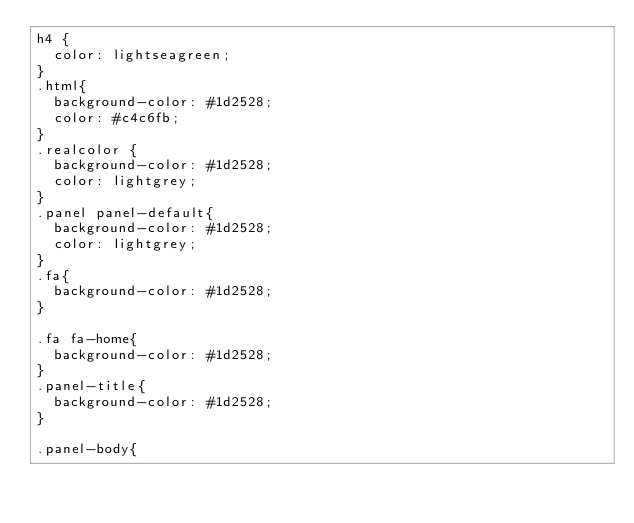Convert code to text. <code><loc_0><loc_0><loc_500><loc_500><_CSS_>h4 {
	color: lightseagreen;
}
.html{
	background-color: #1d2528;
	color: #c4c6fb;
}
.realcolor {
	background-color: #1d2528;
	color: lightgrey;
}
.panel panel-default{
	background-color: #1d2528;
	color: lightgrey;
}
.fa{
	background-color: #1d2528;
}

.fa fa-home{
	background-color: #1d2528;
}
.panel-title{
	background-color: #1d2528;
}

.panel-body{</code> 